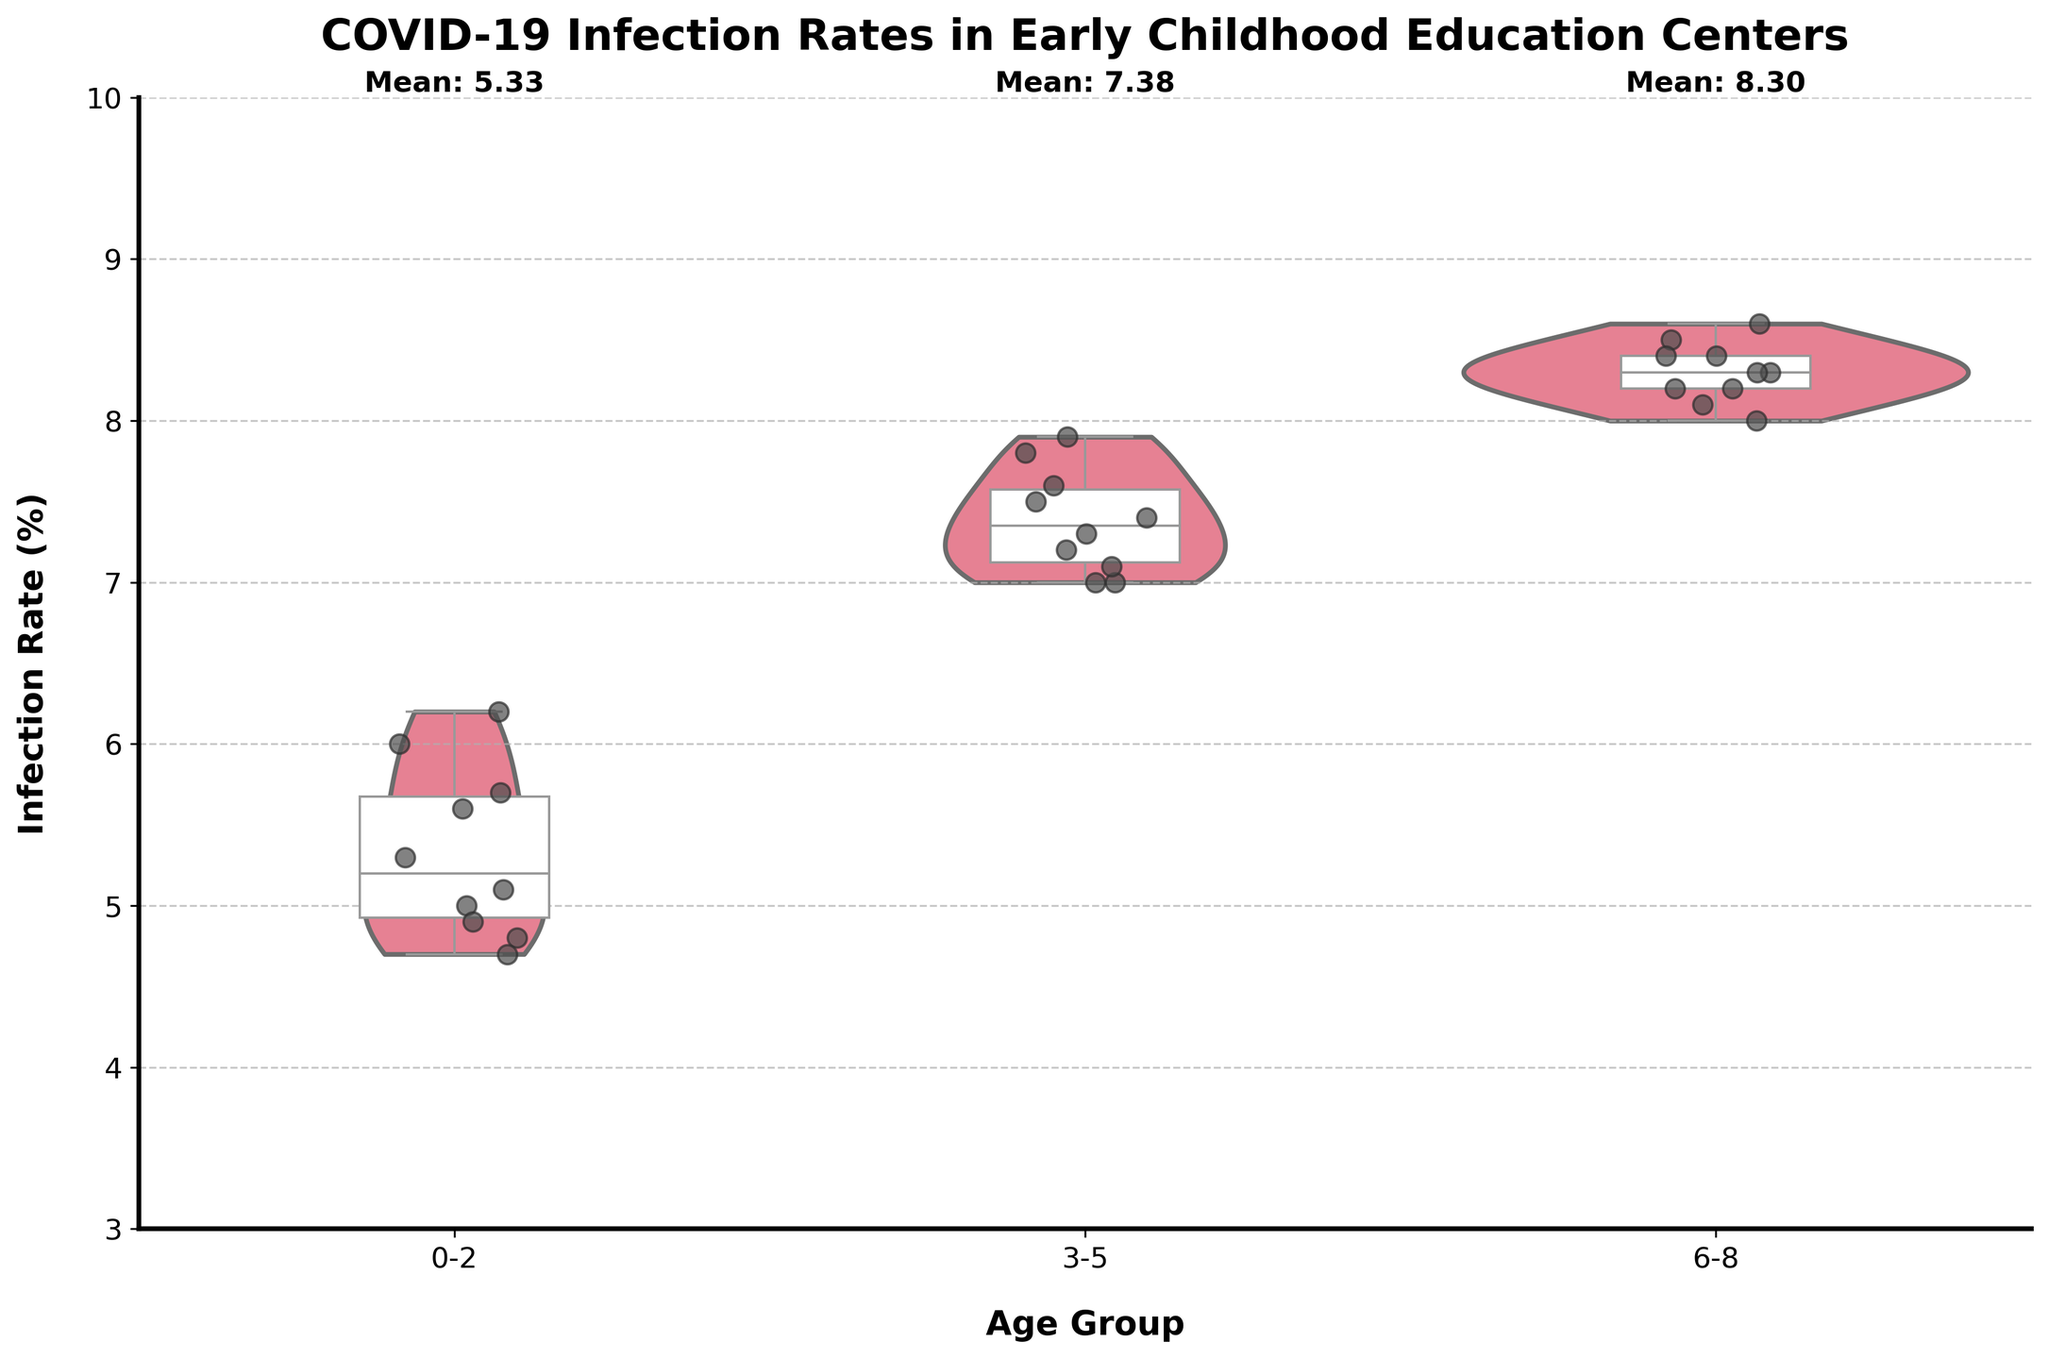How many age groups are visually represented on the chart? The chart displays three distinct categories on the x-axis, each representing different age groups: 0-2, 3-5, and 6-8.
Answer: 3 What is the title of the chart? The title is displayed at the top of the chart, indicating the focus of the visualization.
Answer: COVID-19 Infection Rates in Early Childhood Education Centers Which age group has the highest mean infection rate? Each group has a displayed mean value indicated by the annotation "Mean" near the top of each group.
Answer: 6-8 How does the median infection rate of the 0-2 age group compare to the 3-5 age group? The median is indicated by the thick bar inside the box plot within each violin plot. Comparing their positions shows the medians of 0-2 and 3-5.
Answer: The median of 3-5 is higher What are the minimum and maximum infection rates observed in the 6-8 age group? The minimum and maximum values can be observed by looking at the whiskers of the box plot, which extend from the box within the violin plot for the 6-8 age group.
Answer: Minimum: 8.0, Maximum: 8.6 What is the range of infection rates in the 3-5 age group? The range is calculated using the maximum and minimum values of the 3-5 age group, observable by their whisker ends.
Answer: 0.9 (7.9 - 7.0) Which age group shows the most variability in infection rates? The spread of the data is reflected in the width of the violin plot and the length of the whiskers for each group. The 0-2 group shows the most spread in both violin plot width and whisker length.
Answer: 0-2 In which age group do the quartiles seem the closest together? By observing the lengths of the boxes within the violin plots (indicating interquartile range), it is apparent that the 6-8 age group has the shortest box.
Answer: 6-8 Is the infection rate distribution for the 3-5 age group symmetrical? By examining the shape of the violin plot for the 3-5 age group, we can observe whether it is evenly distributed on both sides of the median line.
Answer: Yes, it appears symmetrical Which age group has the most outliers? Outliers are indicated by individual points outside the whiskers of the box plot. Since the plots have no outliers plotted beyond their whiskers, no group has outliers.
Answer: None 